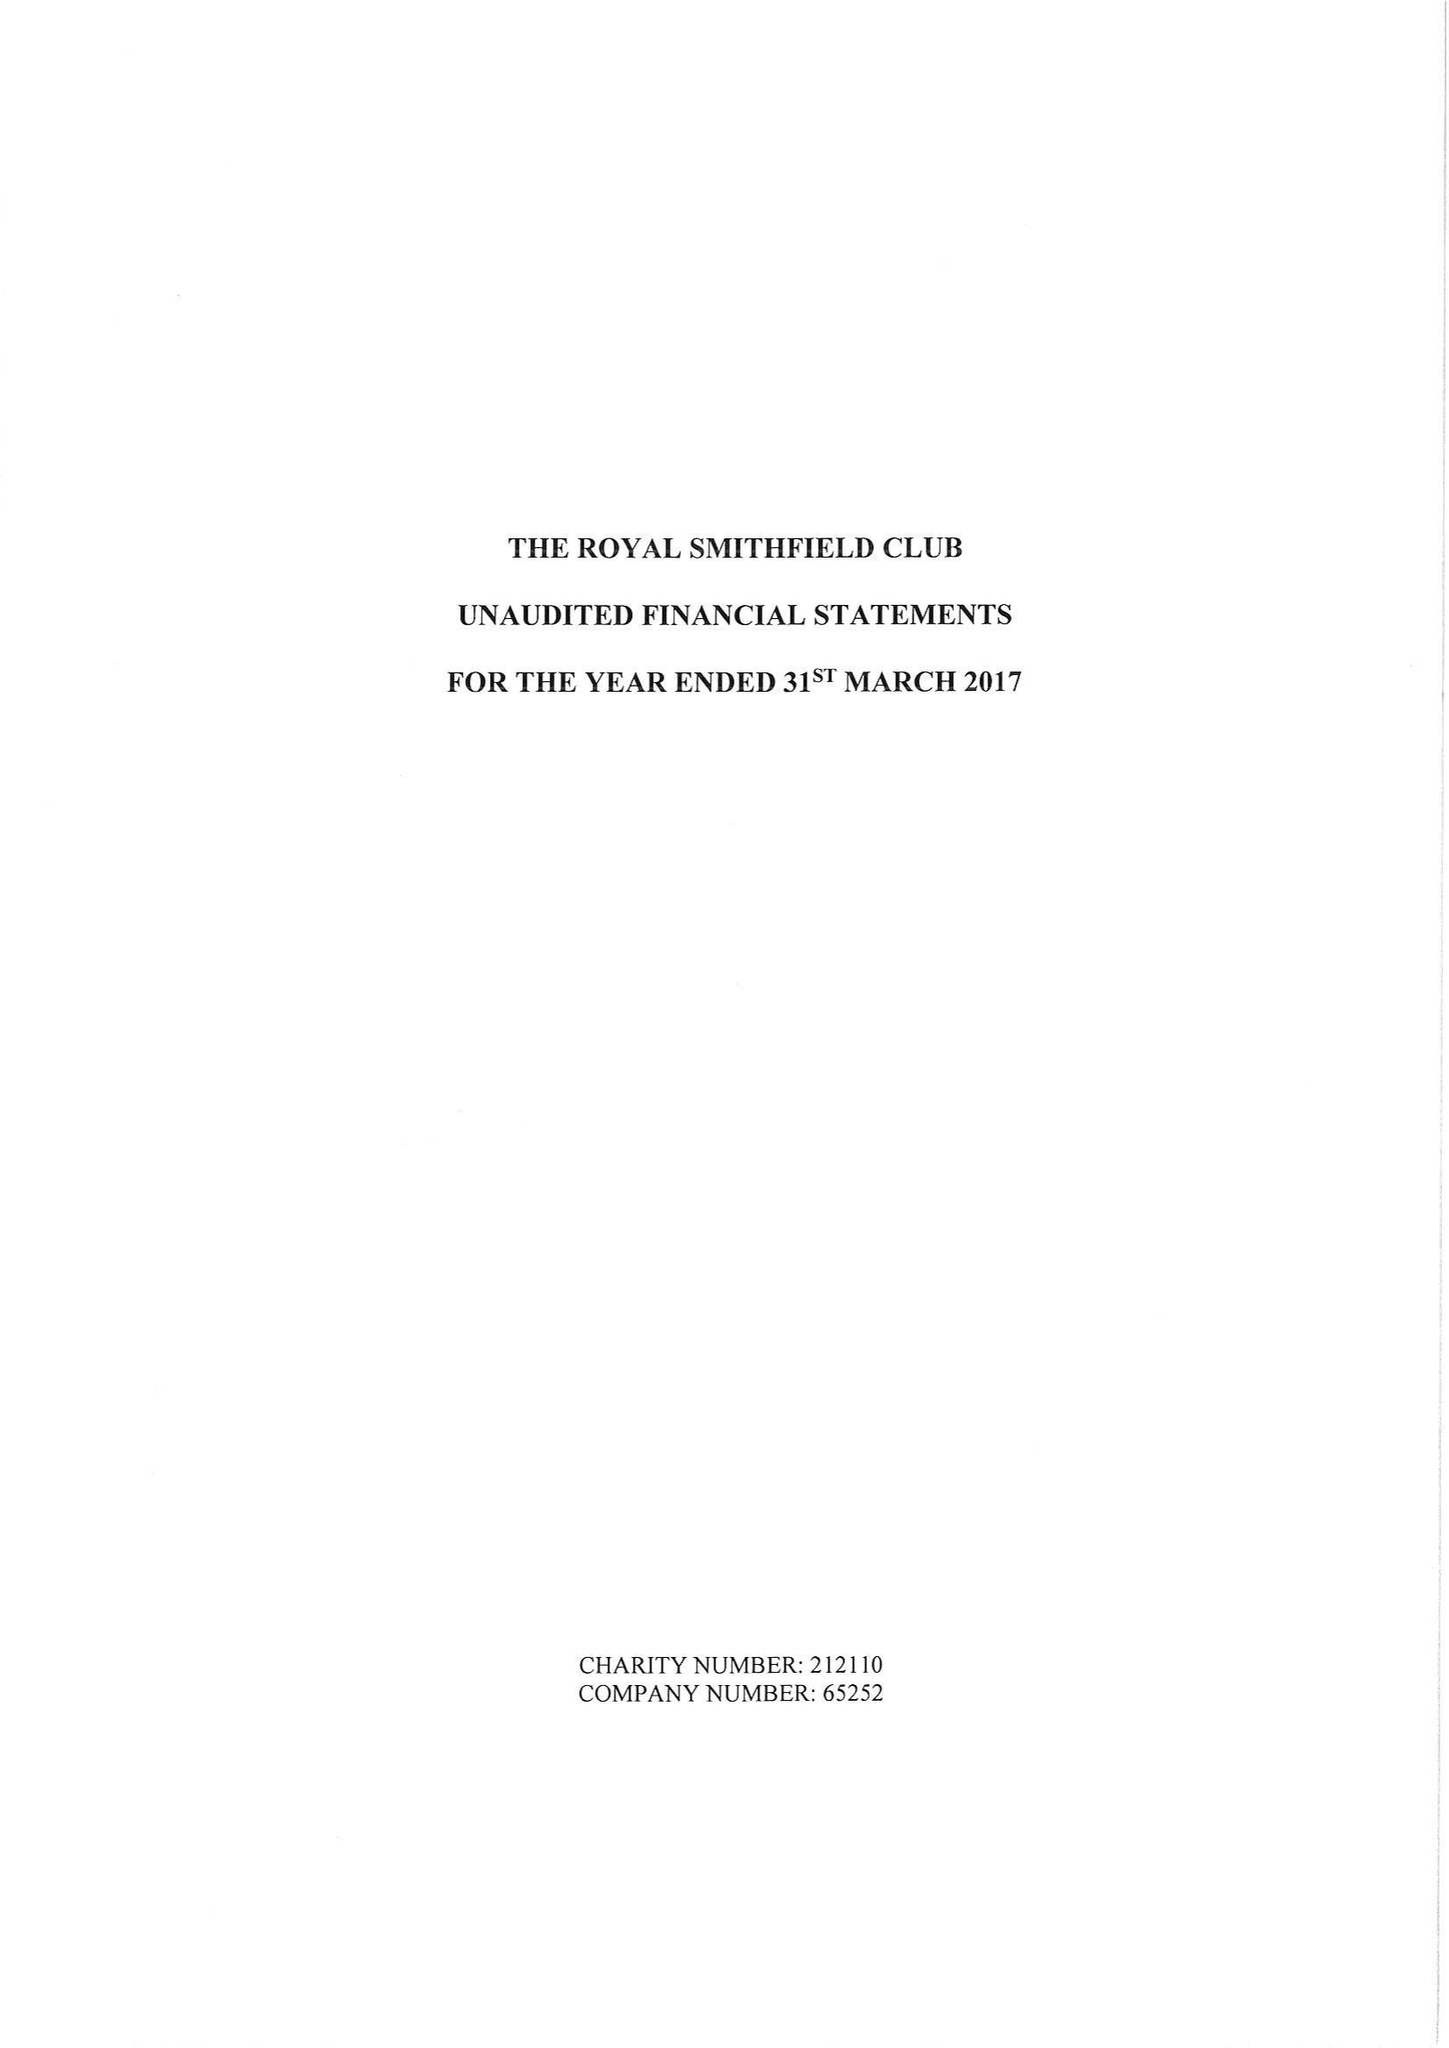What is the value for the address__postcode?
Answer the question using a single word or phrase. BA14 8FA 